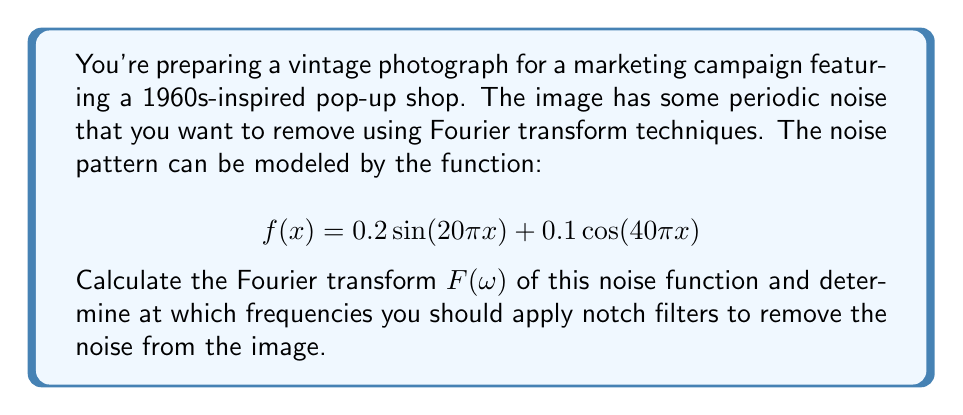Provide a solution to this math problem. To solve this problem, we need to calculate the Fourier transform of the given function and identify the frequencies where the noise appears.

1) The Fourier transform of a sine function $\sin(ax)$ is given by:
   $$\mathcal{F}\{\sin(ax)\} = \frac{i}{2}[\delta(\omega+a) - \delta(\omega-a)]$$

2) The Fourier transform of a cosine function $\cos(ax)$ is given by:
   $$\mathcal{F}\{\cos(ax)\} = \frac{1}{2}[\delta(\omega+a) + \delta(\omega-a)]$$

3) For our function $f(x) = 0.2\sin(20\pi x) + 0.1\cos(40\pi x)$, we can apply linearity of the Fourier transform:

   $$F(\omega) = 0.2 \cdot \mathcal{F}\{\sin(20\pi x)\} + 0.1 \cdot \mathcal{F}\{\cos(40\pi x)\}$$

4) Substituting the Fourier transforms:

   $$F(\omega) = 0.2 \cdot \frac{i}{2}[\delta(\omega+20\pi) - \delta(\omega-20\pi)] + 0.1 \cdot \frac{1}{2}[\delta(\omega+40\pi) + \delta(\omega-40\pi)]$$

5) Simplifying:

   $$F(\omega) = 0.1i[\delta(\omega+20\pi) - \delta(\omega-20\pi)] + 0.05[\delta(\omega+40\pi) + \delta(\omega-40\pi)]$$

6) The delta functions in this result indicate that the noise appears at frequencies $\omega = \pm20\pi$ and $\omega = \pm40\pi$.

Therefore, to remove the noise, you should apply notch filters at these frequencies.
Answer: Apply notch filters at frequencies $\omega = \pm20\pi$ and $\omega = \pm40\pi$ to remove the noise from the vintage photograph. 